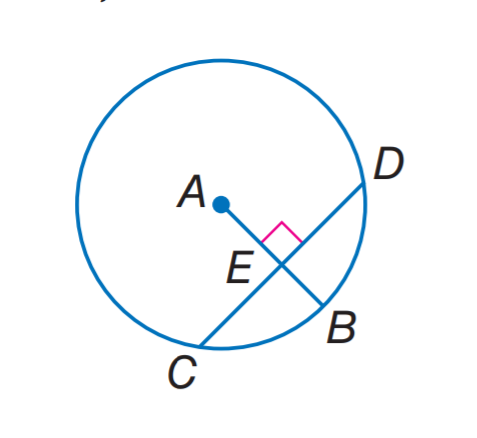Answer the mathemtical geometry problem and directly provide the correct option letter.
Question: In A, the radius is 14 and C D = 22. Find E B. Round to the nearest hundredth.
Choices: A: 3.72 B: 5.34 C: 8.66 D: 16.97 B 